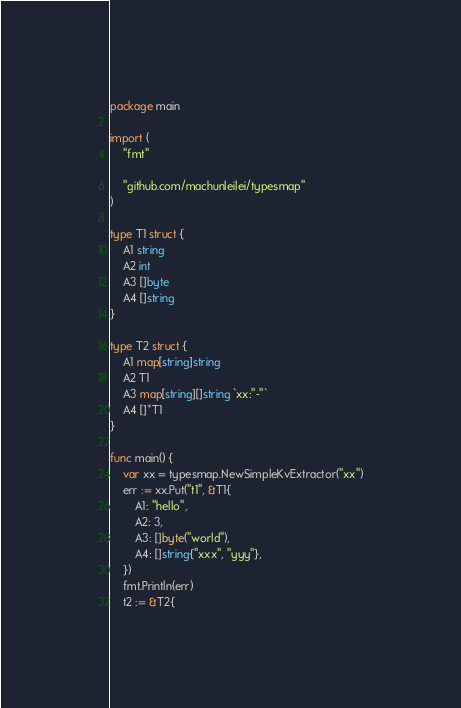<code> <loc_0><loc_0><loc_500><loc_500><_Go_>package main

import (
	"fmt"

	"github.com/machunleilei/typesmap"
)

type T1 struct {
	A1 string
	A2 int
	A3 []byte
	A4 []string
}

type T2 struct {
	A1 map[string]string
	A2 T1
	A3 map[string][]string `xx:"-"`
	A4 []*T1
}

func main() {
	var xx = typesmap.NewSimpleKvExtractor("xx")
	err := xx.Put("t1", &T1{
		A1: "hello",
		A2: 3,
		A3: []byte("world"),
		A4: []string{"xxx", "yyy"},
	})
	fmt.Println(err)
	t2 := &T2{</code> 